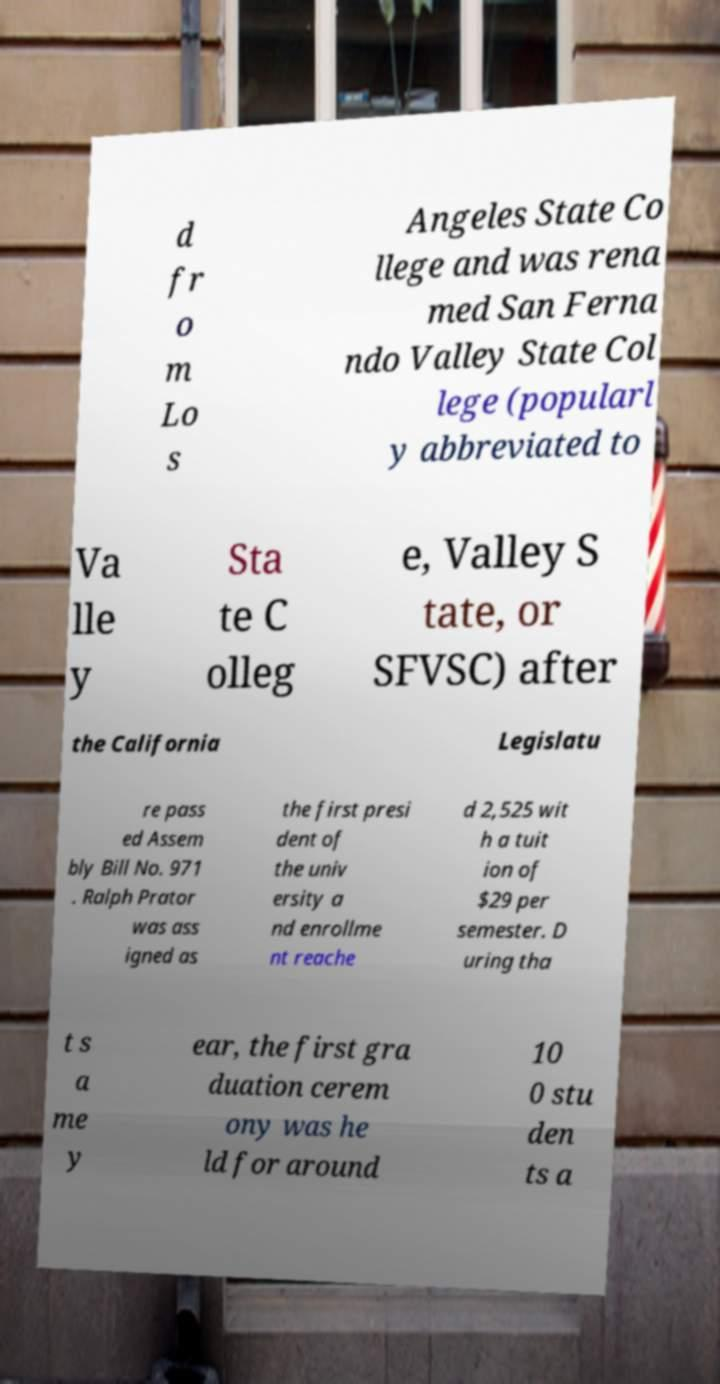Could you assist in decoding the text presented in this image and type it out clearly? d fr o m Lo s Angeles State Co llege and was rena med San Ferna ndo Valley State Col lege (popularl y abbreviated to Va lle y Sta te C olleg e, Valley S tate, or SFVSC) after the California Legislatu re pass ed Assem bly Bill No. 971 . Ralph Prator was ass igned as the first presi dent of the univ ersity a nd enrollme nt reache d 2,525 wit h a tuit ion of $29 per semester. D uring tha t s a me y ear, the first gra duation cerem ony was he ld for around 10 0 stu den ts a 